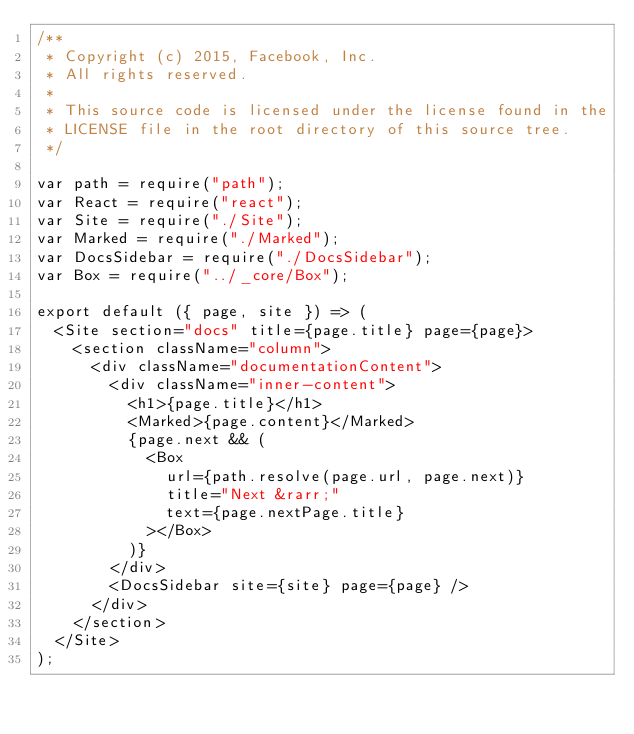<code> <loc_0><loc_0><loc_500><loc_500><_JavaScript_>/**
 * Copyright (c) 2015, Facebook, Inc.
 * All rights reserved.
 *
 * This source code is licensed under the license found in the
 * LICENSE file in the root directory of this source tree.
 */

var path = require("path");
var React = require("react");
var Site = require("./Site");
var Marked = require("./Marked");
var DocsSidebar = require("./DocsSidebar");
var Box = require("../_core/Box");

export default ({ page, site }) => (
  <Site section="docs" title={page.title} page={page}>
    <section className="column">
      <div className="documentationContent">
        <div className="inner-content">
          <h1>{page.title}</h1>
          <Marked>{page.content}</Marked>
          {page.next && (
            <Box
              url={path.resolve(page.url, page.next)}
              title="Next &rarr;"
              text={page.nextPage.title}
            ></Box>
          )}
        </div>
        <DocsSidebar site={site} page={page} />
      </div>
    </section>
  </Site>
);
</code> 